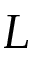Convert formula to latex. <formula><loc_0><loc_0><loc_500><loc_500>L</formula> 